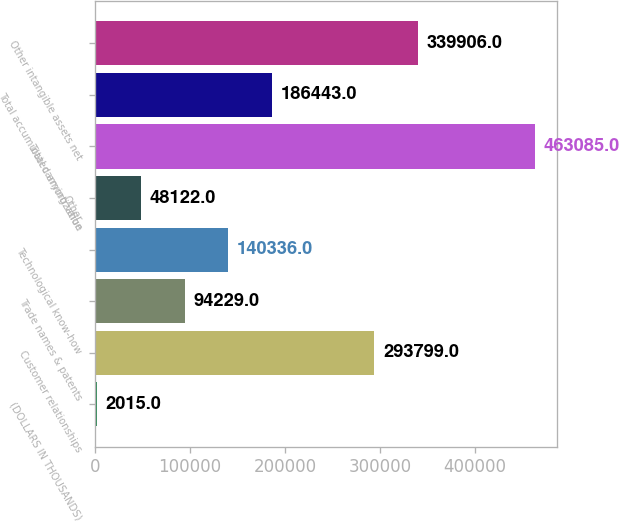Convert chart. <chart><loc_0><loc_0><loc_500><loc_500><bar_chart><fcel>(DOLLARS IN THOUSANDS)<fcel>Customer relationships<fcel>Trade names & patents<fcel>Technological know-how<fcel>Other<fcel>Total carrying value<fcel>Total accumulated amortization<fcel>Other intangible assets net<nl><fcel>2015<fcel>293799<fcel>94229<fcel>140336<fcel>48122<fcel>463085<fcel>186443<fcel>339906<nl></chart> 